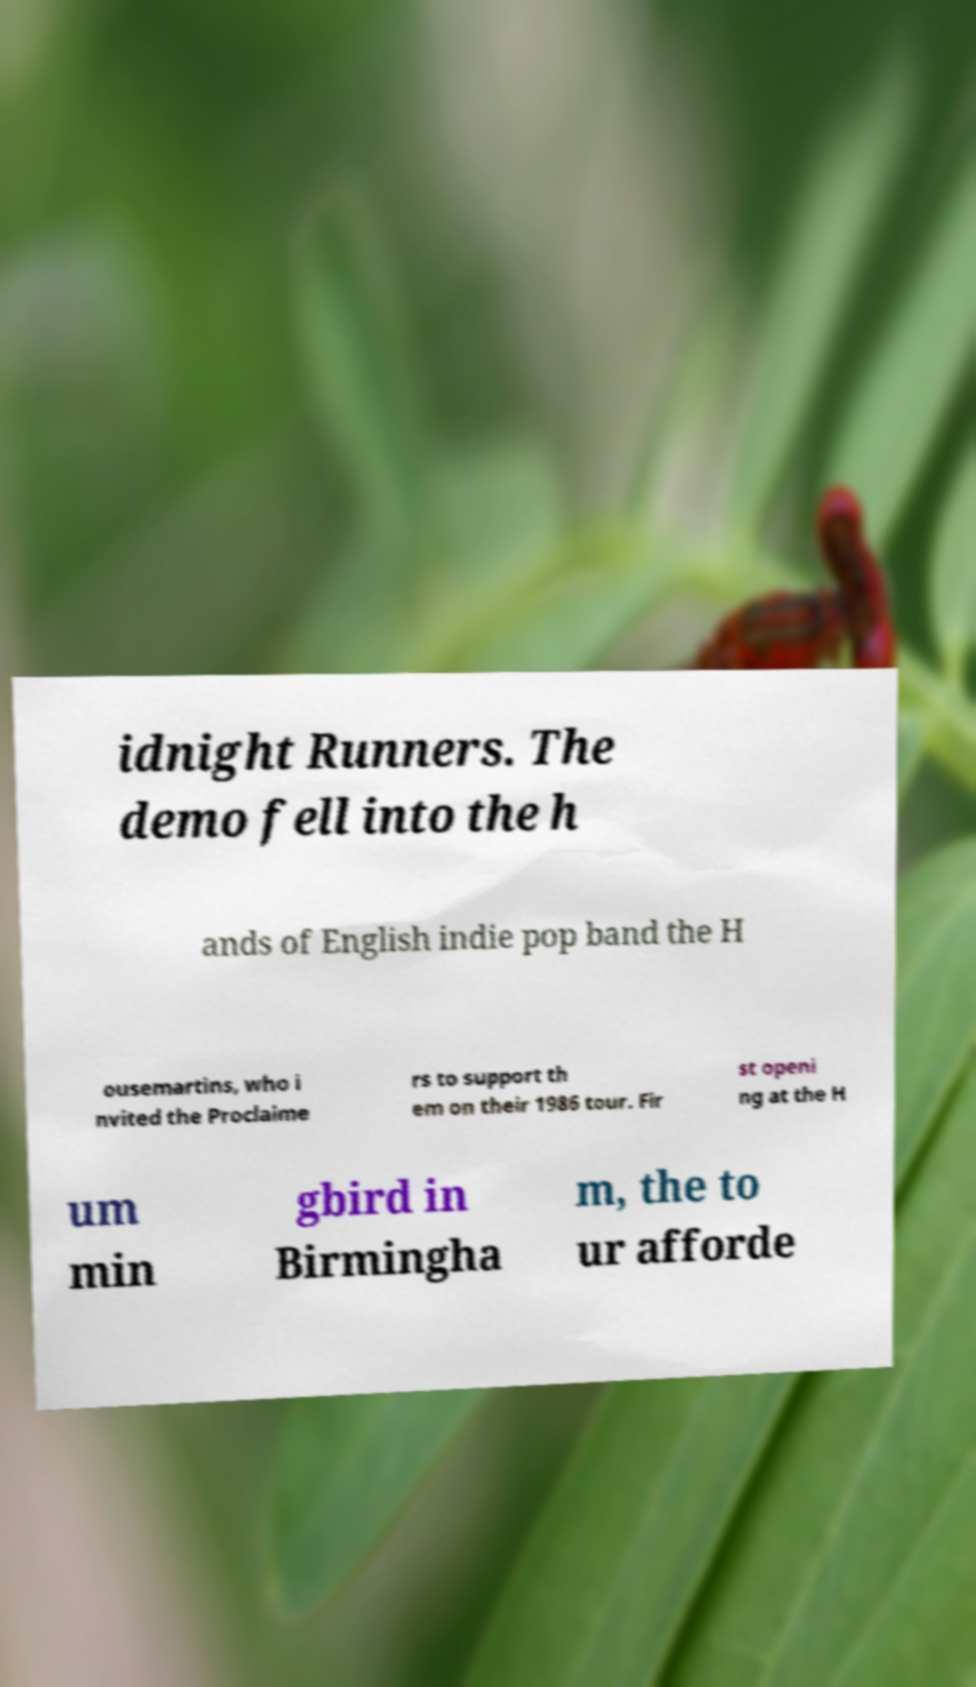Could you assist in decoding the text presented in this image and type it out clearly? idnight Runners. The demo fell into the h ands of English indie pop band the H ousemartins, who i nvited the Proclaime rs to support th em on their 1986 tour. Fir st openi ng at the H um min gbird in Birmingha m, the to ur afforde 